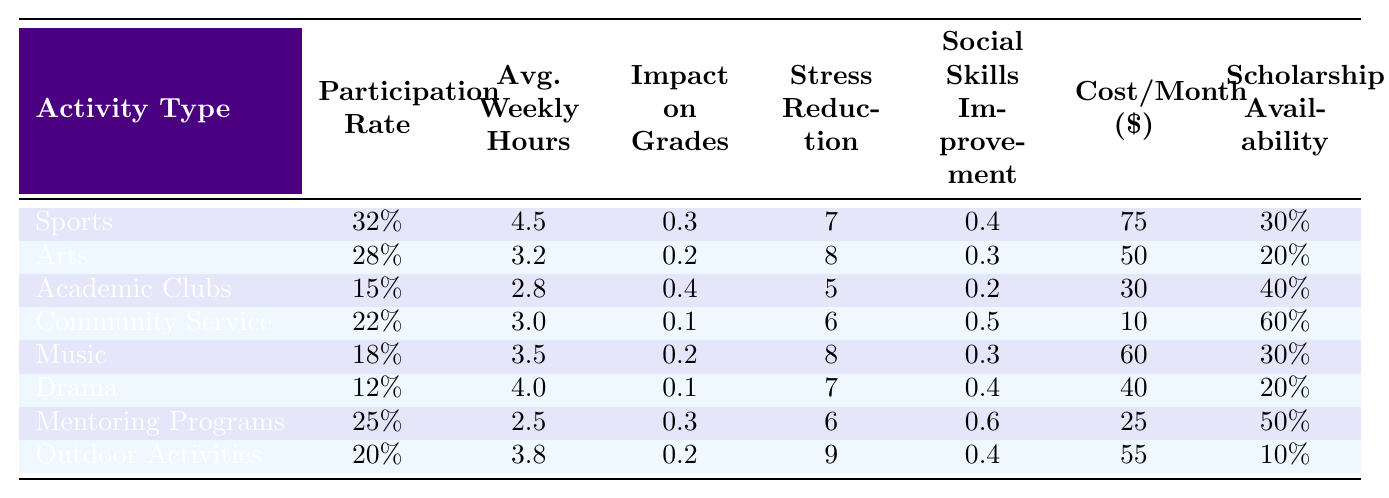What is the participation rate for Arts? The table shows that the participation rate for Arts is listed directly under the Participation Rate column at 28%.
Answer: 28% Which activity has the highest impact on grades? Looking through the Impact on Grades column, Academic Clubs has the highest score at 0.4, indicating the most significant positive effect on grades.
Answer: Academic Clubs What is the average weekly hours for participating in Sports? The table indicates that the average weekly hours for Sports is 4.5, which is noted directly under the Avg. Weekly Hours column.
Answer: 4.5 Is the stress reduction score higher for Music than for Drama? The Stress Reduction scores are 8 for Music and 7 for Drama. Since 8 is greater than 7, Music does have a higher score.
Answer: Yes How many activities have a participation rate of 20% or lower? The activities with a participation rate of 20% or lower are Academic Clubs (15%), Drama (12%), and Outdoor Activities (20%). This totals 3 activities.
Answer: 3 What is the difference in participation rate between Sports and Community Service? The participation rate for Sports is 32%, and for Community Service, it is 22%. The difference is 32% - 22% = 10%.
Answer: 10% What is the average cost per month of participating in Arts, Music, and Drama? The costs are 50 (Arts), 60 (Music), and 40 (Drama). The average cost is (50 + 60 + 40) / 3 = 150 / 3 = 50.
Answer: 50 Which activity has the lowest average weekly hours? The average weekly hours for each activity are compared, and Mentoring Programs has the lowest at 2.5 hours.
Answer: Mentoring Programs What is the overall stress reduction score for all activities? To find the overall stress reduction score, sum the individual scores (7 + 8 + 5 + 6 + 8 + 7 + 6 + 9) and divide by the number of activities (8), resulting in a score of 56 / 8 = 7.
Answer: 7 Which activity has the highest scholarship availability, and what is that percentage? Scholarship Availability shows that Community Service has the highest value at 60%, indicating it is the activity with the most opportunities for scholarships.
Answer: Community Service, 60% 